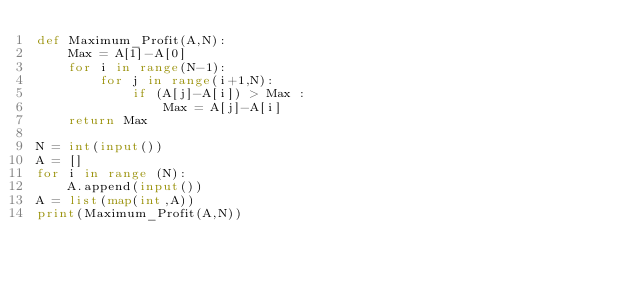Convert code to text. <code><loc_0><loc_0><loc_500><loc_500><_Python_>def Maximum_Profit(A,N):
    Max = A[1]-A[0]
    for i in range(N-1):
        for j in range(i+1,N):
            if (A[j]-A[i]) > Max :
                Max = A[j]-A[i]
    return Max

N = int(input())
A = [] 
for i in range (N):
    A.append(input())
A = list(map(int,A))
print(Maximum_Profit(A,N))
</code> 